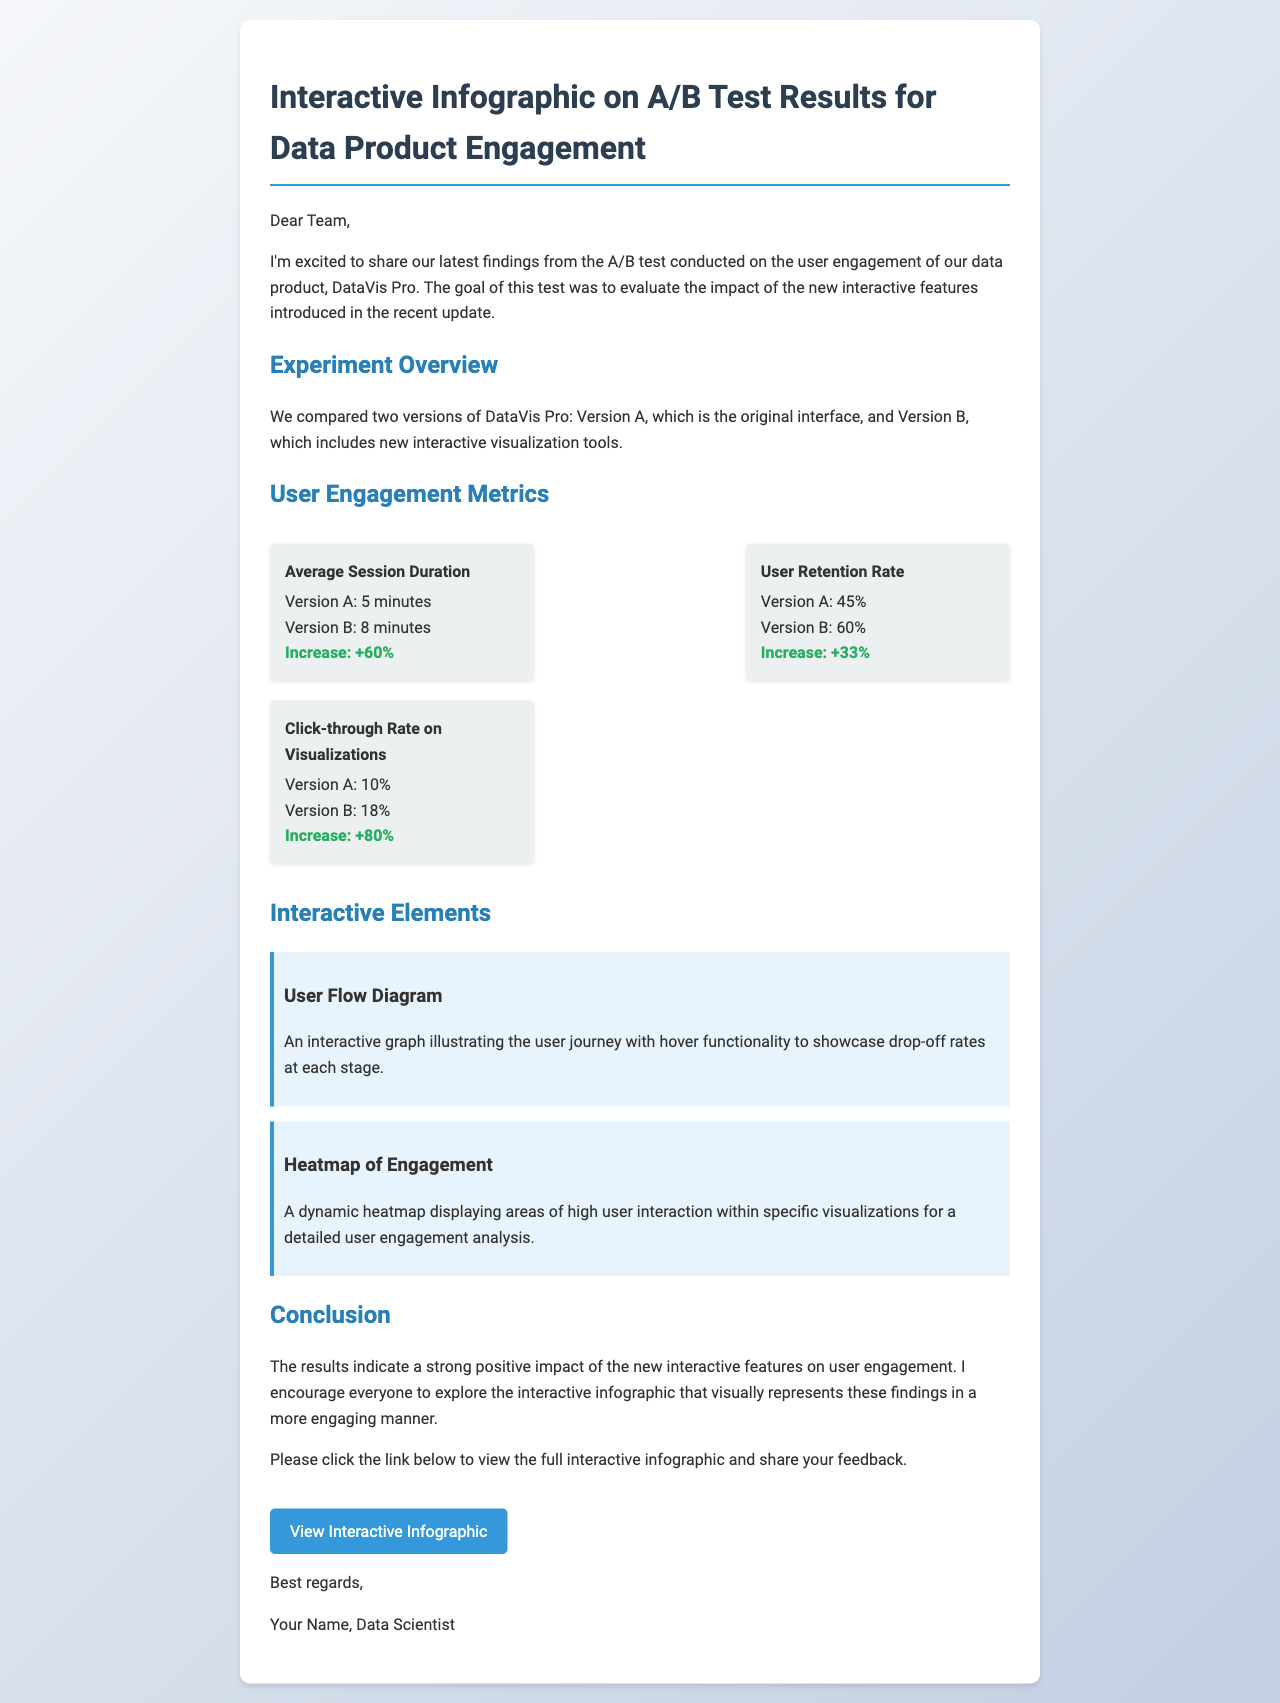What was the average session duration for Version A? The average session duration for Version A is directly stated in the user engagement metrics section of the document.
Answer: 5 minutes What is the increase in the click-through rate from Version A to Version B? The increase in the click-through rate is calculated based on the numbers provided in the metrics, which shows the difference between Version A and Version B.
Answer: +80% What is the user retention rate for Version B? The user retention rate for Version B is provided in the user engagement metrics.
Answer: 60% What are the two interactive elements mentioned in the document? The interactive elements are specifically listed in the interactive elements section of the document.
Answer: User Flow Diagram, Heatmap of Engagement What conclusion can be drawn about the effect of interactive features on user engagement? The conclusion regarding the effect of interactive features is discussed in the conclusion section, outlining the impact on user engagement.
Answer: Strong positive impact What interactive feature allows for exploring user journey drop-off rates? This feature is described in the interactive elements section, particularly focusing on user flow.
Answer: User Flow Diagram What was the average session duration for Version B? The average session duration for Version B is stated in the user engagement metrics section, making it easy to retrieve.
Answer: 8 minutes 